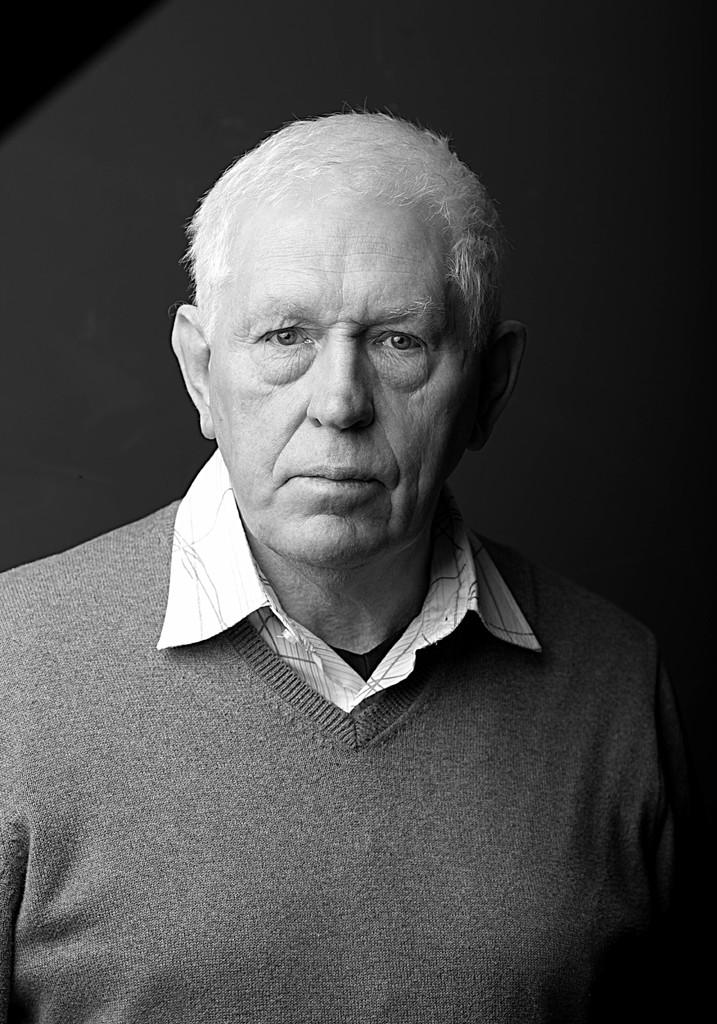Who is present in the image? There is a man in the image. What is the man wearing? The man is wearing clothes, including a sweater. What is the color scheme of the image? The image is black and white. Can you see a rabbit playing with the man in the image? There is no rabbit present in the image; it only features a man wearing clothes, including a sweater. 